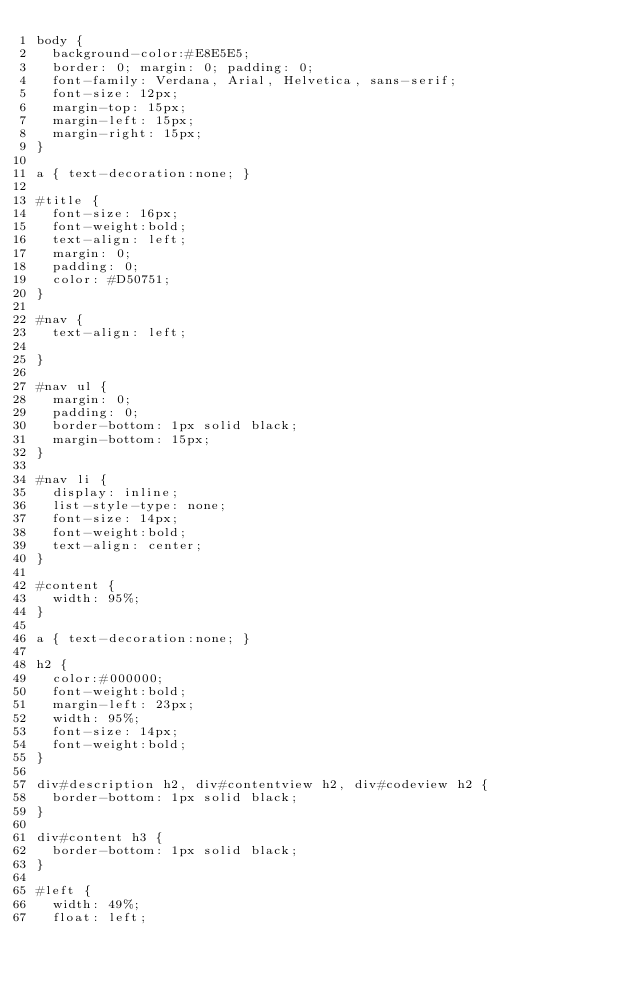<code> <loc_0><loc_0><loc_500><loc_500><_CSS_>body {
  background-color:#E8E5E5;
	border: 0; margin: 0; padding: 0;
	font-family: Verdana, Arial, Helvetica, sans-serif;
  font-size: 12px; 	
  margin-top: 15px;
  margin-left: 15px;
  margin-right: 15px;
}

a {	text-decoration:none; }

#title {
  font-size: 16px; 
  font-weight:bold;
  text-align: left;
  margin: 0;
  padding: 0;
  color: #D50751;
}

#nav {
	text-align: left;
	
}

#nav ul {
  margin: 0;
  padding: 0;
  border-bottom: 1px solid black;	
  margin-bottom: 15px;
}

#nav li {
	display: inline;
	list-style-type: none;
  font-size: 14px; 
  font-weight:bold;
	text-align: center;
}

#content {
	width: 95%;
}

a {	text-decoration:none; }

h2 {
	color:#000000; 
  font-weight:bold;
	margin-left: 23px;
	width: 95%;
  font-size: 14px; 
  font-weight:bold;
}

div#description h2, div#contentview h2, div#codeview h2 {
	border-bottom: 1px solid black;
}

div#content h3 {
	border-bottom: 1px solid black;
}

#left {
  width: 49%;
  float: left;</code> 